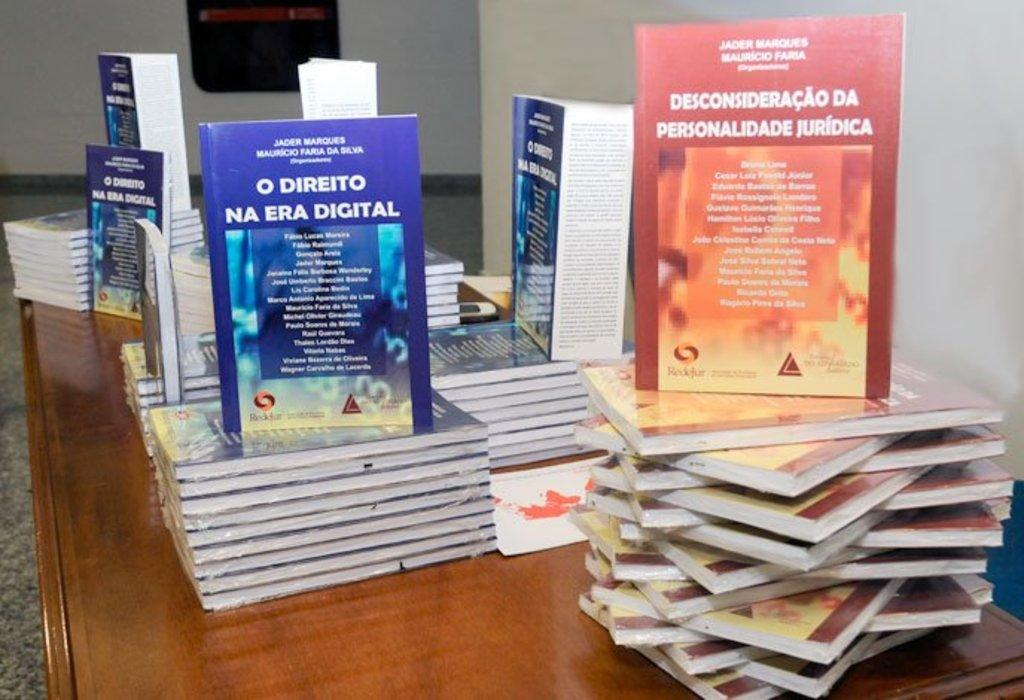<image>
Describe the image concisely. Blue Book called NA Era Digital on top of other books. 